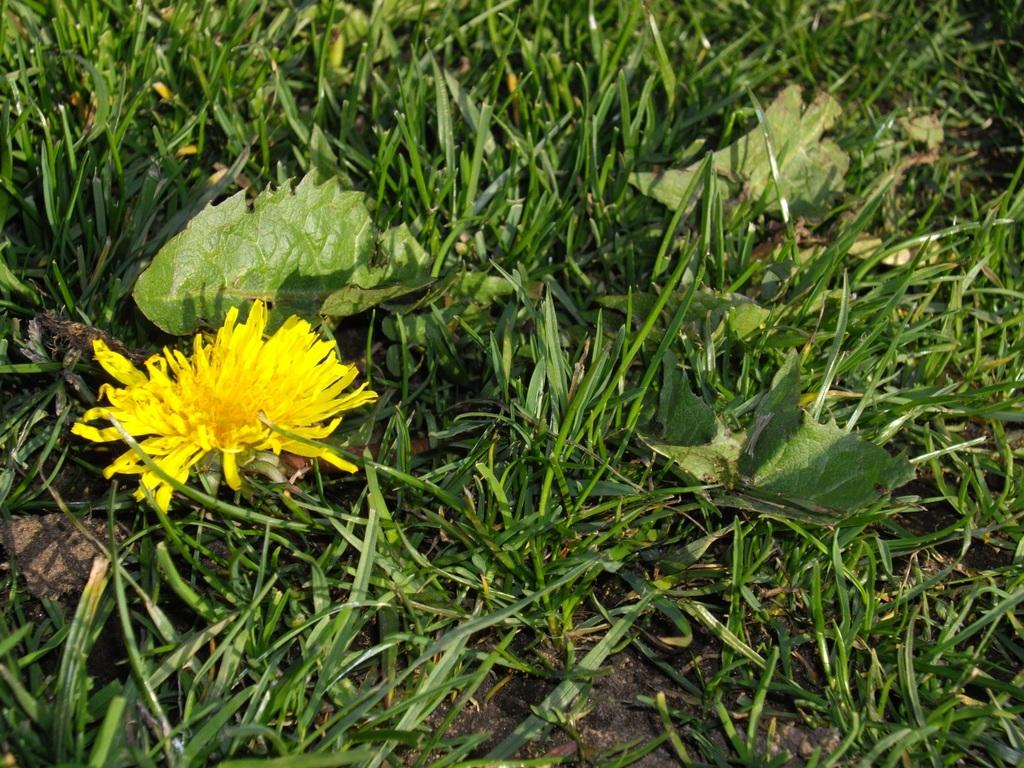What type of flower is in the image? There is a yellow color flower in the image. Where is the flower located? The flower is on the grass. What is the color of the grass? The grass is green in color. How many pigs are playing with the flower in the image? There are no pigs present in the image, and therefore no such activity can be observed. 